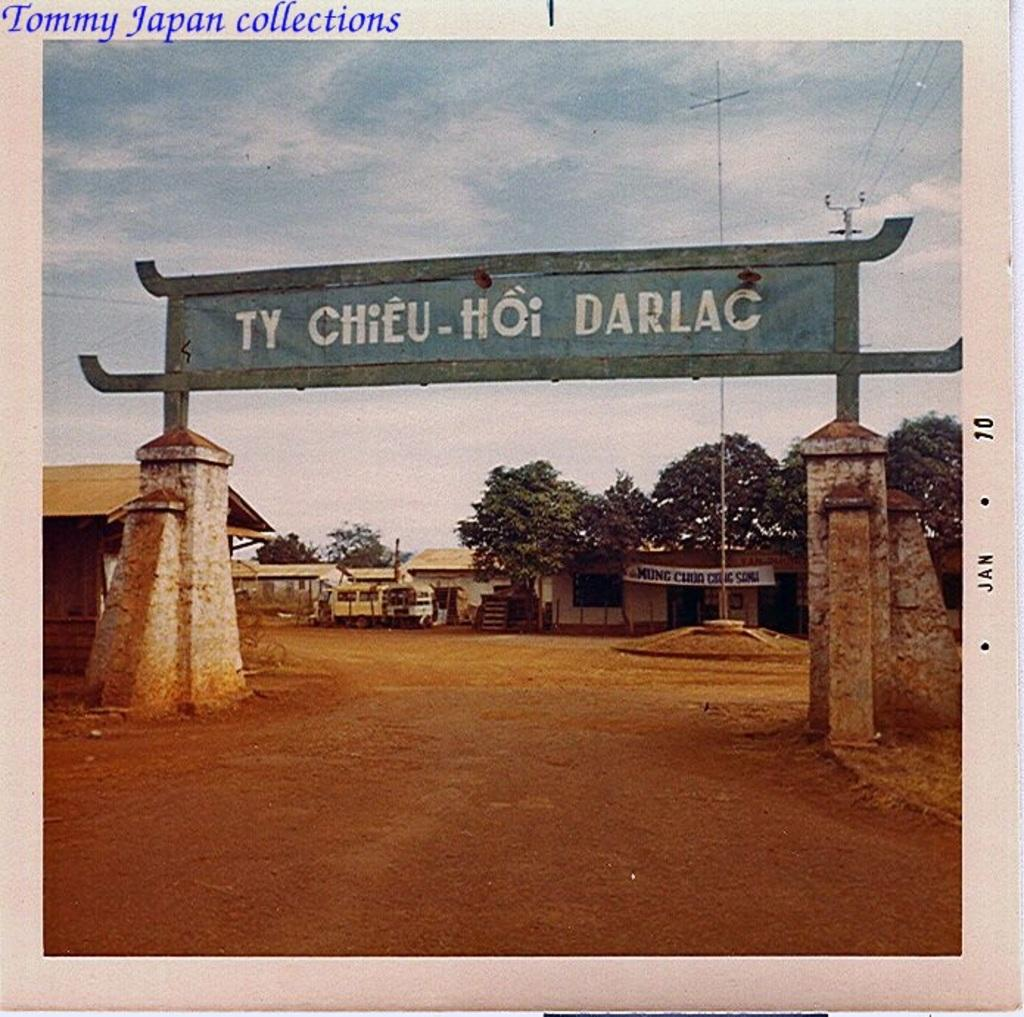<image>
Share a concise interpretation of the image provided. An entryway with pillars and a sign that says Ty Chieu-Hoi Darlac. 